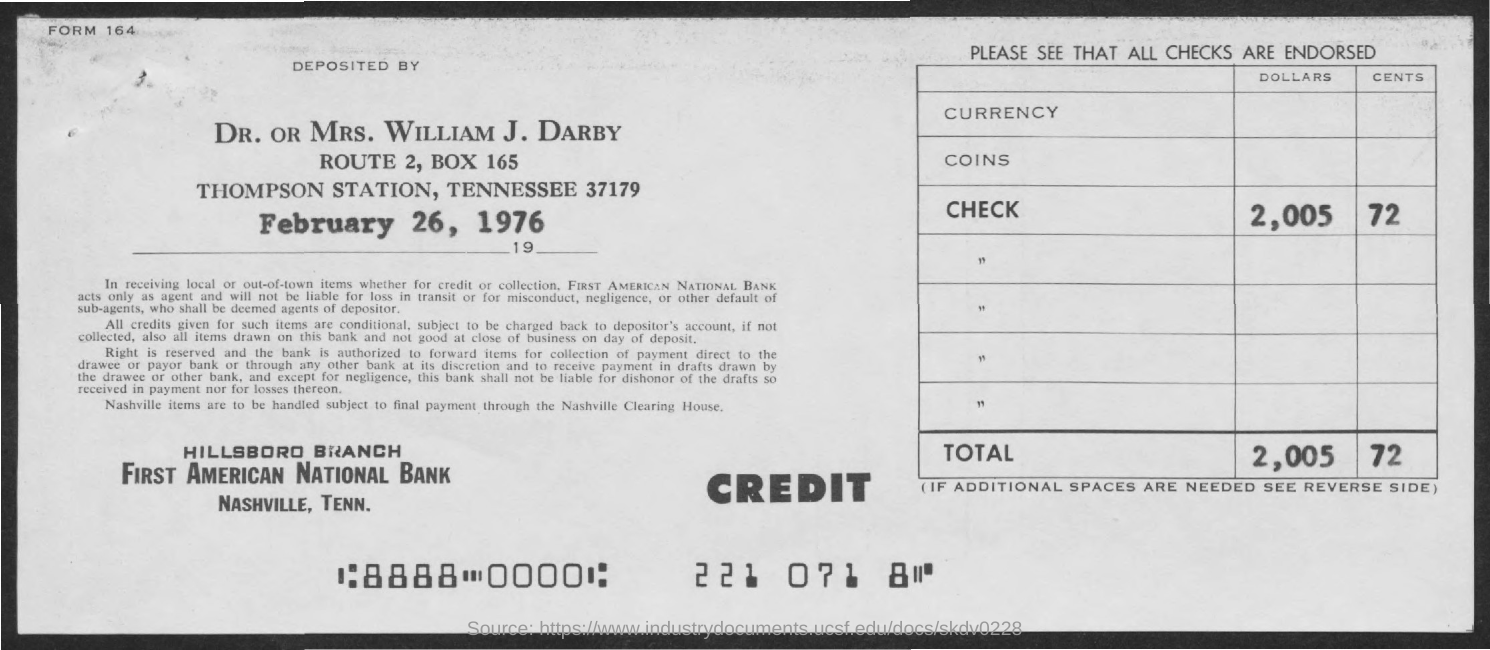List a handful of essential elements in this visual. The deposit of the amount occurred on February 26, 1976. 